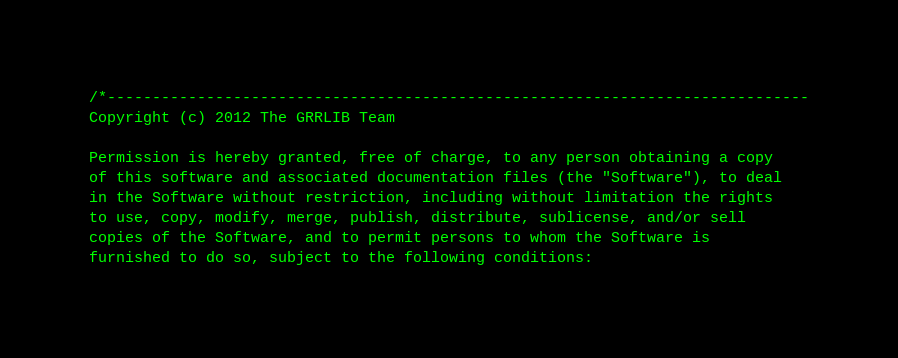Convert code to text. <code><loc_0><loc_0><loc_500><loc_500><_C_>/*------------------------------------------------------------------------------
Copyright (c) 2012 The GRRLIB Team

Permission is hereby granted, free of charge, to any person obtaining a copy
of this software and associated documentation files (the "Software"), to deal
in the Software without restriction, including without limitation the rights
to use, copy, modify, merge, publish, distribute, sublicense, and/or sell
copies of the Software, and to permit persons to whom the Software is
furnished to do so, subject to the following conditions:
</code> 